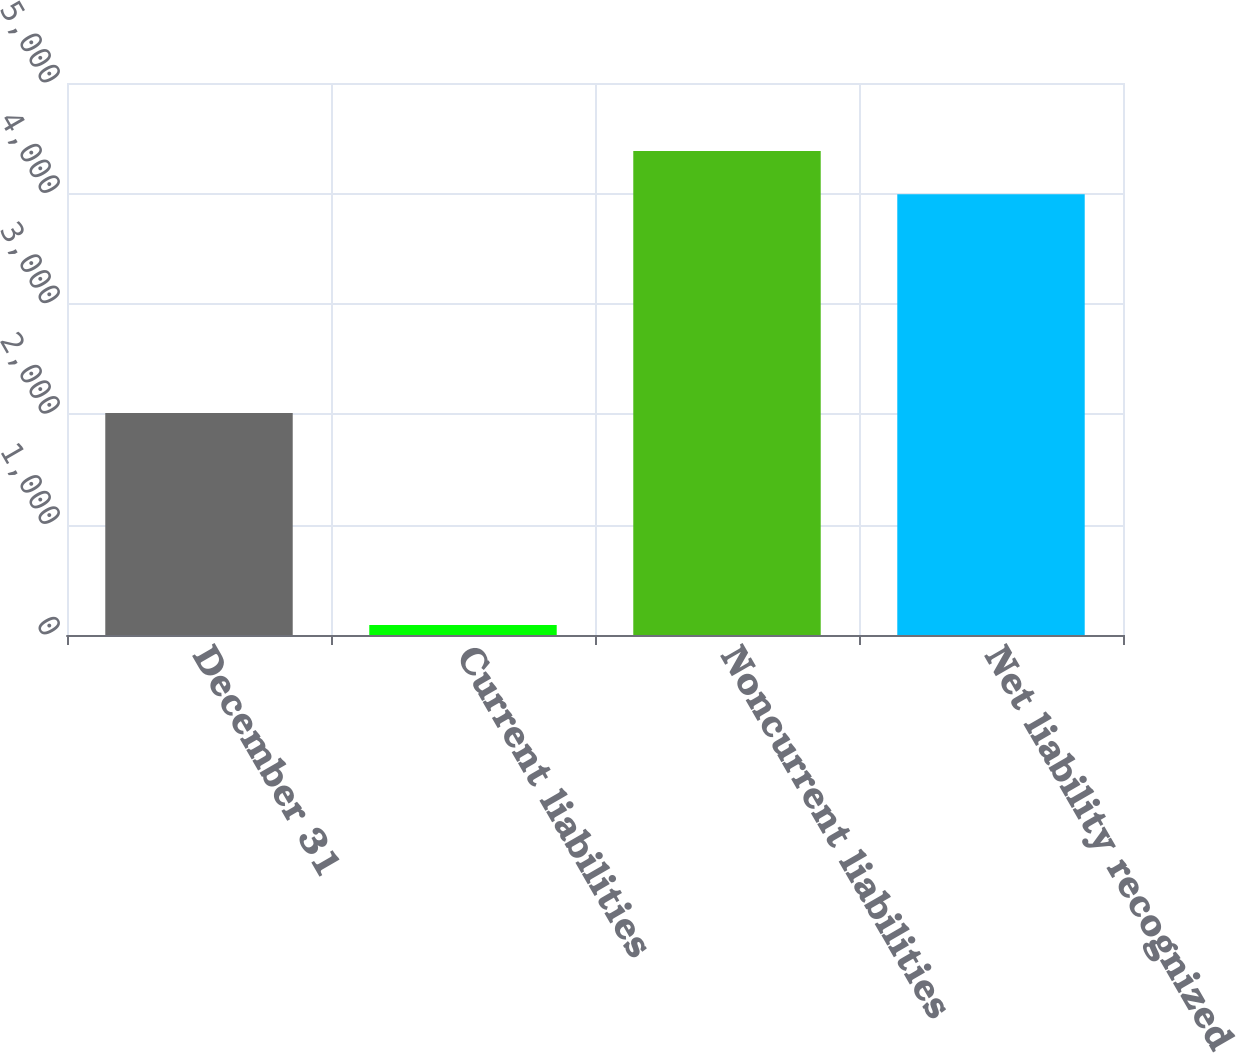<chart> <loc_0><loc_0><loc_500><loc_500><bar_chart><fcel>December 31<fcel>Current liabilities<fcel>Noncurrent liabilities<fcel>Net liability recognized<nl><fcel>2011<fcel>90<fcel>4384.2<fcel>3992<nl></chart> 